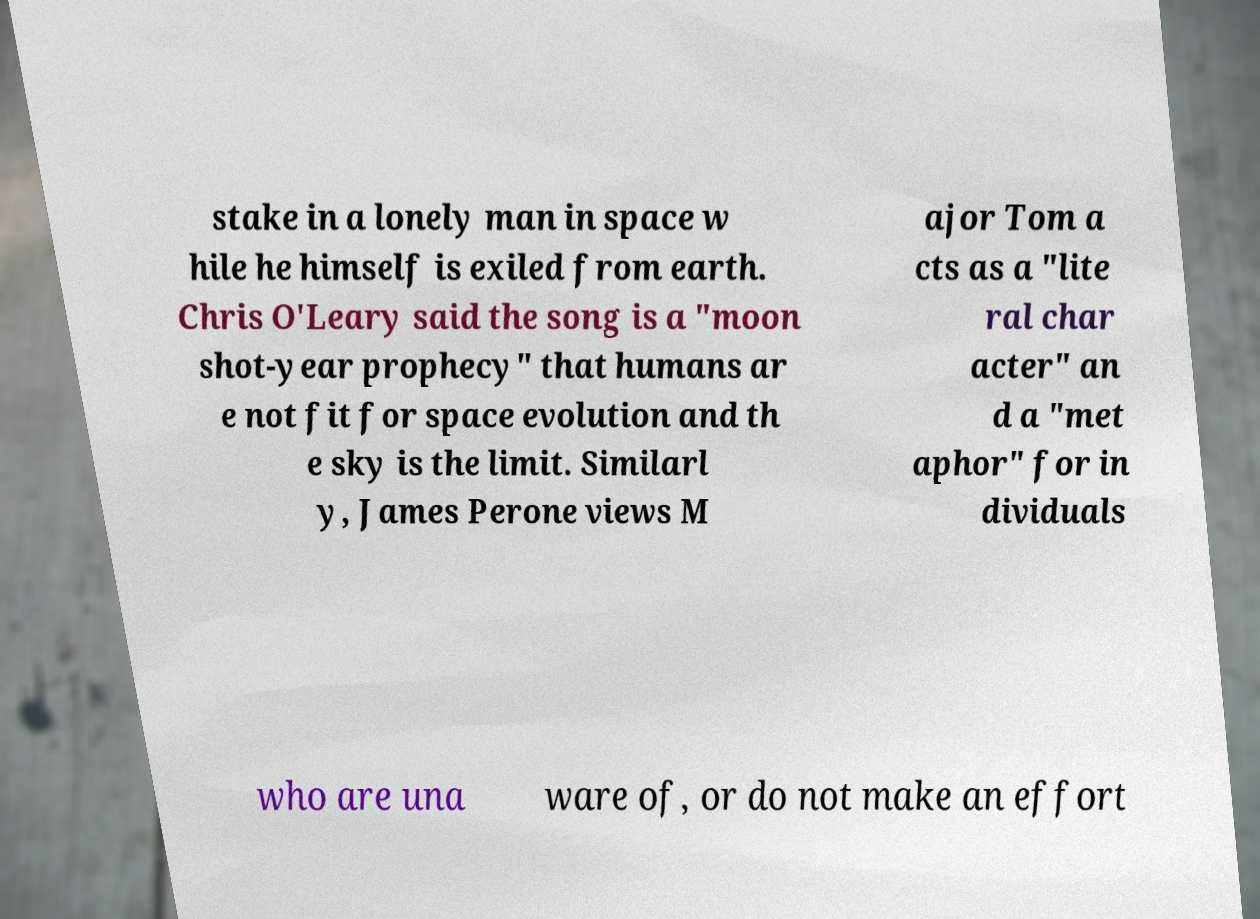Please identify and transcribe the text found in this image. stake in a lonely man in space w hile he himself is exiled from earth. Chris O'Leary said the song is a "moon shot-year prophecy" that humans ar e not fit for space evolution and th e sky is the limit. Similarl y, James Perone views M ajor Tom a cts as a "lite ral char acter" an d a "met aphor" for in dividuals who are una ware of, or do not make an effort 